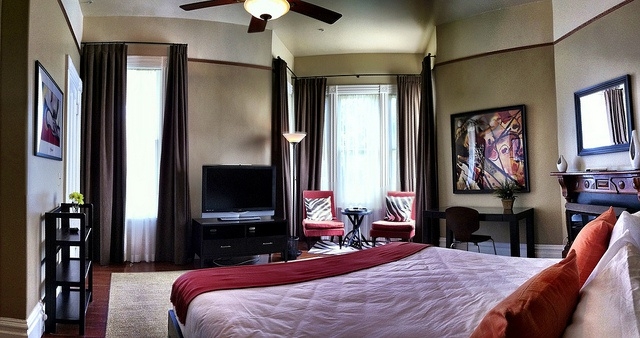Describe the objects in this image and their specific colors. I can see bed in black, darkgray, maroon, and gray tones, tv in black, gray, darkgray, and maroon tones, tv in black, gray, and darkgray tones, dining table in black, gray, and darkgray tones, and chair in black, lightgray, maroon, and brown tones in this image. 